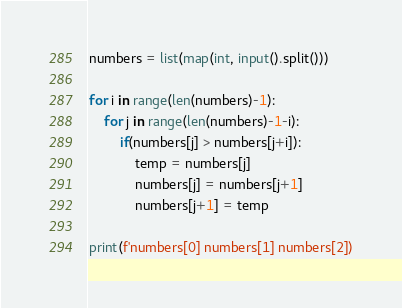Convert code to text. <code><loc_0><loc_0><loc_500><loc_500><_Python_>numbers = list(map(int, input().split()))

for i in range(len(numbers)-1):
    for j in range(len(numbers)-1-i):
        if(numbers[j] > numbers[j+i]):
            temp = numbers[j]
            numbers[j] = numbers[j+1]
            numbers[j+1] = temp
            
print(f'numbers[0] numbers[1] numbers[2])
</code> 